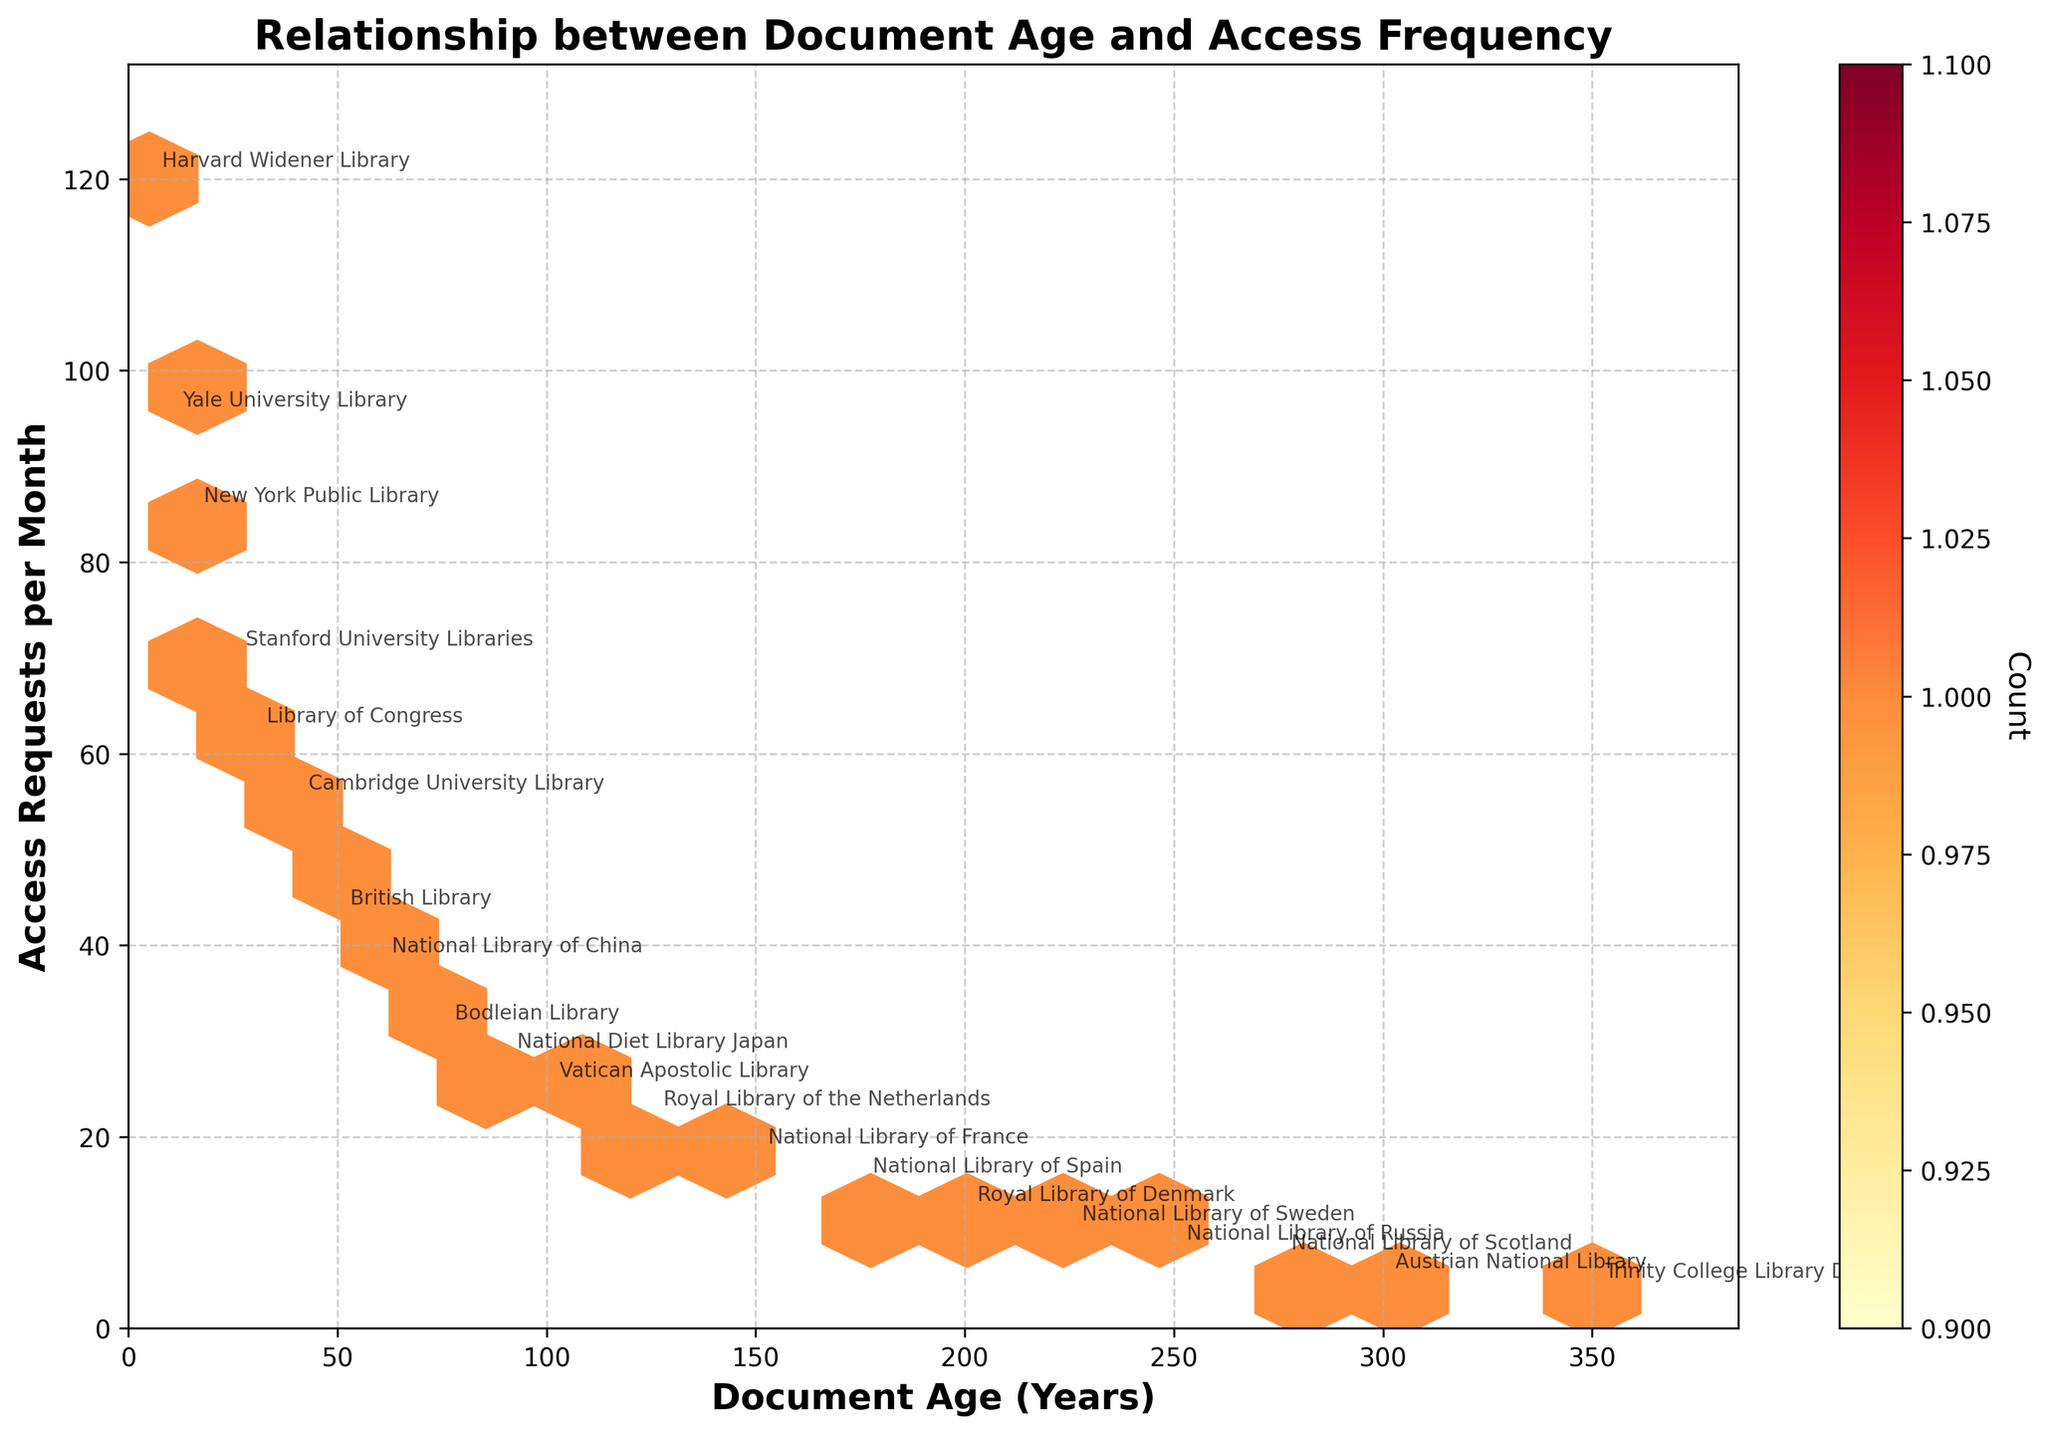what is the title of the figure? The title is usually located at the top of the figure, visually larger and bold, summarizing the content of the plot. Look for it to identify the focus of the figure.
Answer: Relationship between Document Age and Access Frequency How many libraries are labeled in the plot? By counting the individual annotations in the plot, you identify the number of unique library names labeled.
Answer: 20 Which library has the highest frequency of access requests per month? Locate the highest y-value in the plot and identify the corresponding annotation next to it.
Answer: Harvard Widener Library Is there a general trend between document age and frequency of access requests? Examine the overall distribution and direction of the hexbin cells: generally, older documents (higher x-values) appear to have lower access requests (lower y-values).
Answer: Yes, older documents tend to have fewer access requests What is the color of the hexbin cells used to represent the highest density of data points? Identify the color displayed in the hexbin cells where data points are most concentrated. According to the colormap 'YlOrRd', it's the darkest color.
Answer: Dark red Which library represents the oldest document age? Find the largest x-value on the plot and identify the annotated library name closest to it.
Answer: Trinity College Library Dublin Calculate the average frequency of access requests for documents aged 50 years and below. Sum the access_requests values for documents aged 50 years and below, then divide by the count of these documents. (120+85+95+70+55+43) / 6 = 468 / 6.
Answer: 78 How does the access request frequency drop from 100 years to 200 years old documents? Identify the y-values for 100 and 200 years, then calculate the difference. (25 - 12).
Answer: 13 Which two libraries have the closest values in terms of access requests per month? Compare the access request values and identify the two closest values. British Library (43) and Cambridge University Library (40) are closest.
Answer: British Library and Cambridge University Library 